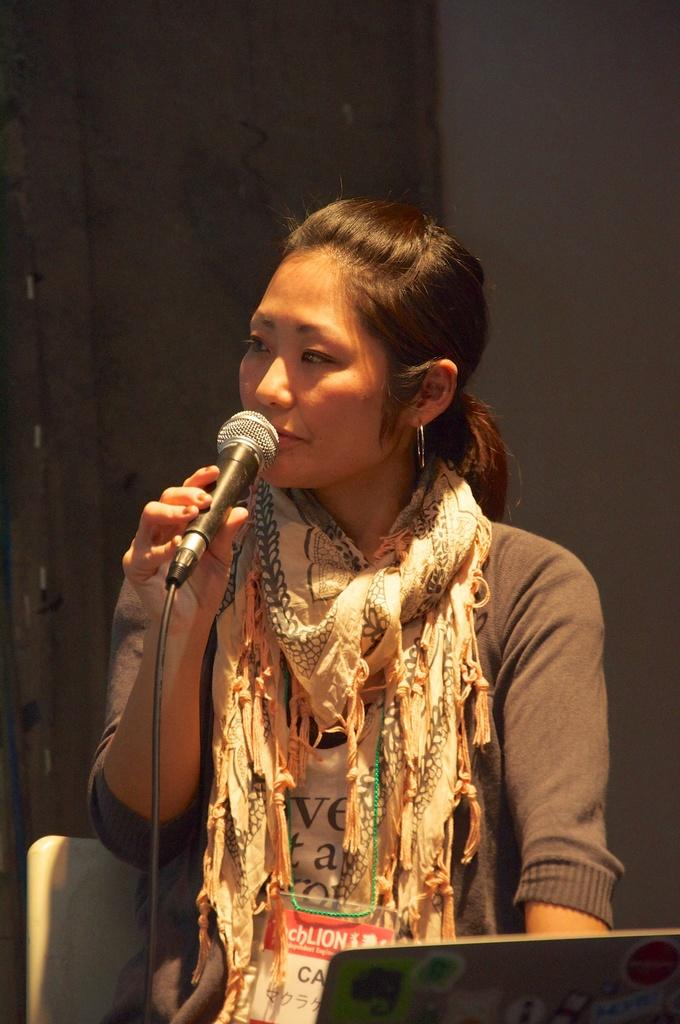Who is the main subject in the image? There is a woman in the image. What is the woman holding in the image? The woman is holding a microphone. What is the woman's position in the image? The woman is sitting on a chair. What can be seen in the background of the image? There is a wall in the background of the image. What is the woman wearing in the image? The woman is wearing a scarf. What type of cracker is the woman eating in the image? There is no cracker present in the image, and the woman is not eating anything. 